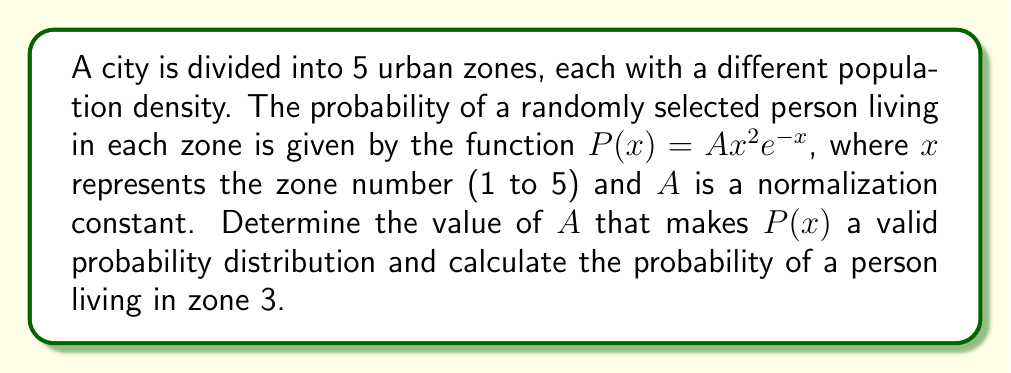What is the answer to this math problem? 1. For $P(x)$ to be a valid probability distribution, the sum of probabilities across all zones must equal 1:

   $$\sum_{x=1}^{5} P(x) = 1$$

2. Substitute the given function:

   $$\sum_{x=1}^{5} Ax^2e^{-x} = 1$$

3. Factor out $A$:

   $$A\sum_{x=1}^{5} x^2e^{-x} = 1$$

4. Calculate the sum (you can use a calculator for this):

   $$A(1e^{-1} + 4e^{-2} + 9e^{-3} + 16e^{-4} + 25e^{-5}) = 1$$
   $$A(0.3679 + 0.5413 + 0.4463 + 0.2176 + 0.0622) = 1$$
   $$A(1.6353) = 1$$

5. Solve for $A$:

   $$A = \frac{1}{1.6353} \approx 0.6115$$

6. Now that we have $A$, we can calculate the probability of a person living in zone 3:

   $$P(3) = A(3^2)e^{-3}$$
   $$P(3) = 0.6115 \cdot 9 \cdot e^{-3}$$
   $$P(3) = 0.6115 \cdot 9 \cdot 0.0498$$
   $$P(3) \approx 0.2739$$
Answer: $A \approx 0.6115$, $P(3) \approx 0.2739$ 